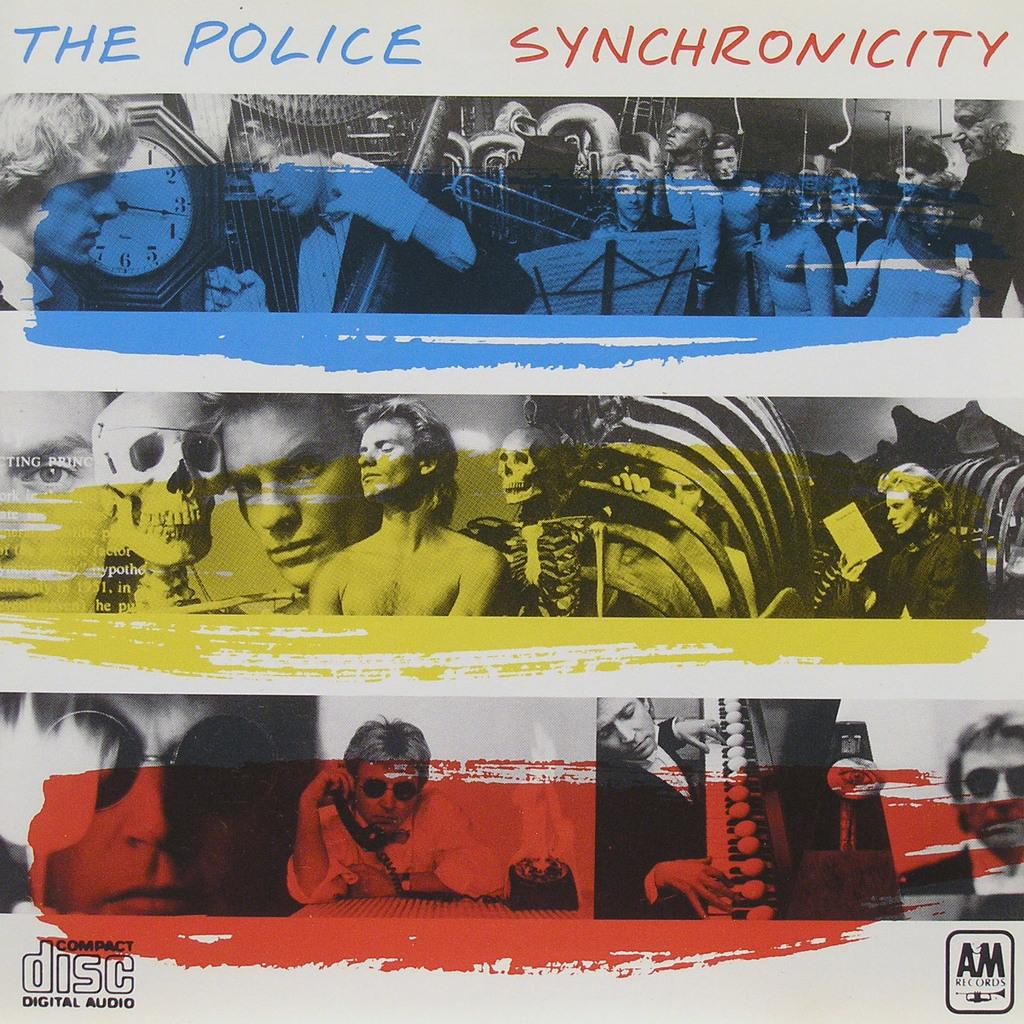<image>
Offer a succinct explanation of the picture presented. An colourful album cover by the band the police. 